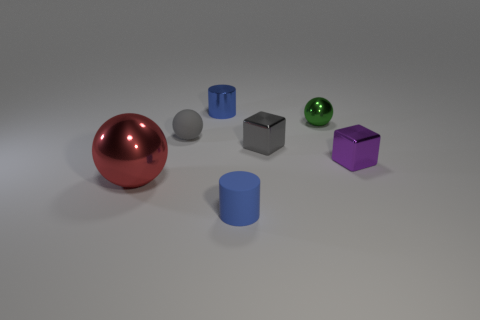Subtract all yellow spheres. Subtract all gray cubes. How many spheres are left? 3 Add 3 gray cubes. How many objects exist? 10 Subtract all cubes. How many objects are left? 5 Add 2 large metallic objects. How many large metallic objects exist? 3 Subtract 0 purple cylinders. How many objects are left? 7 Subtract all purple metallic cubes. Subtract all tiny purple blocks. How many objects are left? 5 Add 5 large things. How many large things are left? 6 